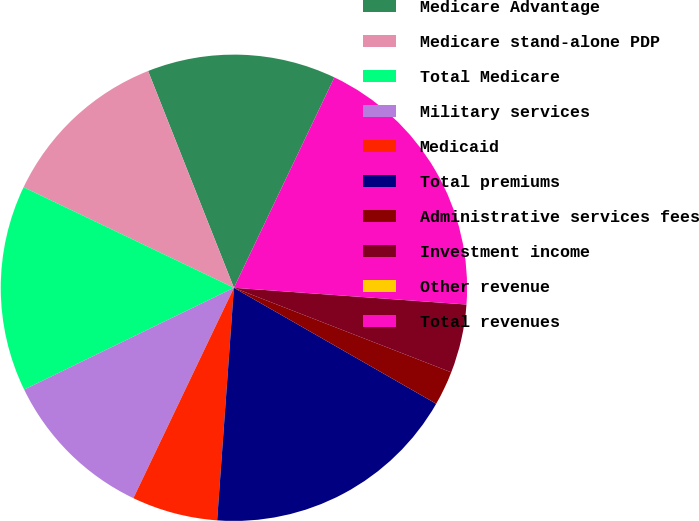<chart> <loc_0><loc_0><loc_500><loc_500><pie_chart><fcel>Medicare Advantage<fcel>Medicare stand-alone PDP<fcel>Total Medicare<fcel>Military services<fcel>Medicaid<fcel>Total premiums<fcel>Administrative services fees<fcel>Investment income<fcel>Other revenue<fcel>Total revenues<nl><fcel>13.09%<fcel>11.9%<fcel>14.29%<fcel>10.71%<fcel>5.95%<fcel>17.86%<fcel>2.38%<fcel>4.76%<fcel>0.0%<fcel>19.05%<nl></chart> 